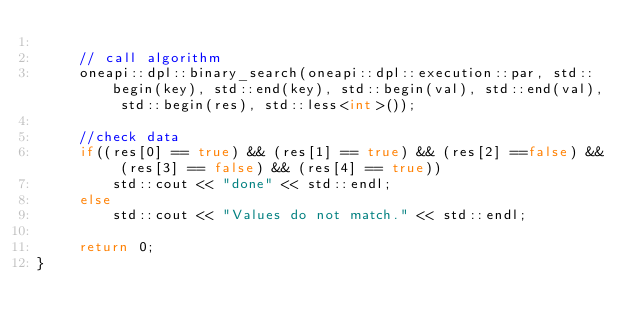Convert code to text. <code><loc_0><loc_0><loc_500><loc_500><_C++_>  
     // call algorithm
     oneapi::dpl::binary_search(oneapi::dpl::execution::par, std::begin(key), std::end(key), std::begin(val), std::end(val), std::begin(res), std::less<int>());

     //check data
     if((res[0] == true) && (res[1] == true) && (res[2] ==false) && (res[3] == false) && (res[4] == true))
         std::cout << "done" << std::endl;
     else
         std::cout << "Values do not match." << std::endl;

     return 0;
}
</code> 